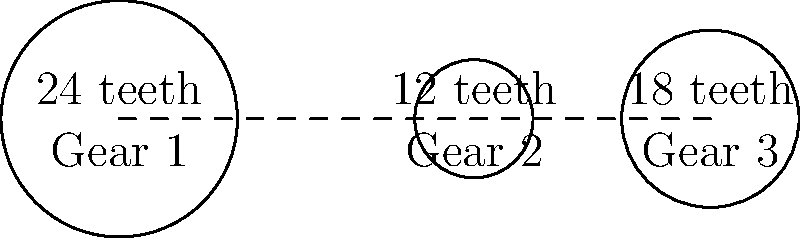In the simple gear train shown above, Gear 1 is the driver gear rotating at 1200 RPM clockwise. Calculate the speed and direction of Gear 3. How might this gear system be analogous to data encryption in a VPN? To solve this problem, we'll follow these steps:

1) First, calculate the gear ratio between Gear 1 and Gear 2:
   $$\text{Gear Ratio}_{1,2} = \frac{\text{Teeth of Gear 2}}{\text{Teeth of Gear 1}} = \frac{12}{24} = \frac{1}{2}$$

2) The speed of Gear 2 will be:
   $$\text{Speed of Gear 2} = \text{Speed of Gear 1} \times \frac{1}{\text{Gear Ratio}_{1,2}} = 1200 \times 2 = 2400 \text{ RPM}$$

3) Gear 2 will rotate in the opposite direction to Gear 1, so counterclockwise.

4) Now, calculate the gear ratio between Gear 2 and Gear 3:
   $$\text{Gear Ratio}_{2,3} = \frac{\text{Teeth of Gear 3}}{\text{Teeth of Gear 2}} = \frac{18}{12} = \frac{3}{2}$$

5) The speed of Gear 3 will be:
   $$\text{Speed of Gear 3} = \text{Speed of Gear 2} \times \frac{1}{\text{Gear Ratio}_{2,3}} = 2400 \times \frac{2}{3} = 1600 \text{ RPM}$$

6) Gear 3 will rotate in the opposite direction to Gear 2, so clockwise.

Analogy to VPN encryption: This gear system can be seen as analogous to data encryption in a VPN. Just as the gears transform the speed and direction of rotation, encryption algorithms in a VPN transform data into an unreadable format. The multiple stages of the gear train are similar to the multiple layers of encryption often used in VPNs, each adding to the complexity and security of the system.
Answer: 1600 RPM clockwise 